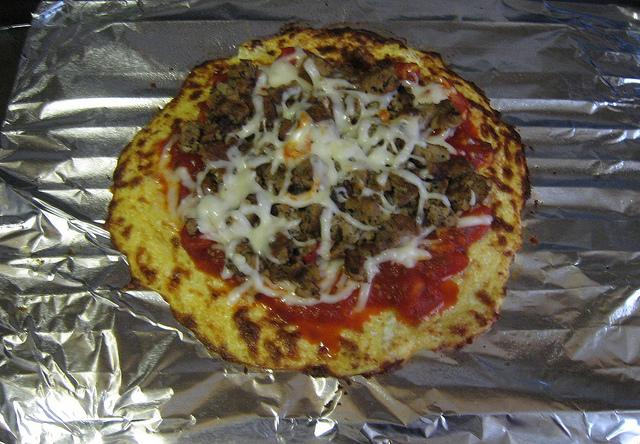Is this a white pizza?
Quick response, please. No. Would you try this type of pizza?
Answer briefly. Yes. What type of material is the pizza sitting on?
Give a very brief answer. Foil. 